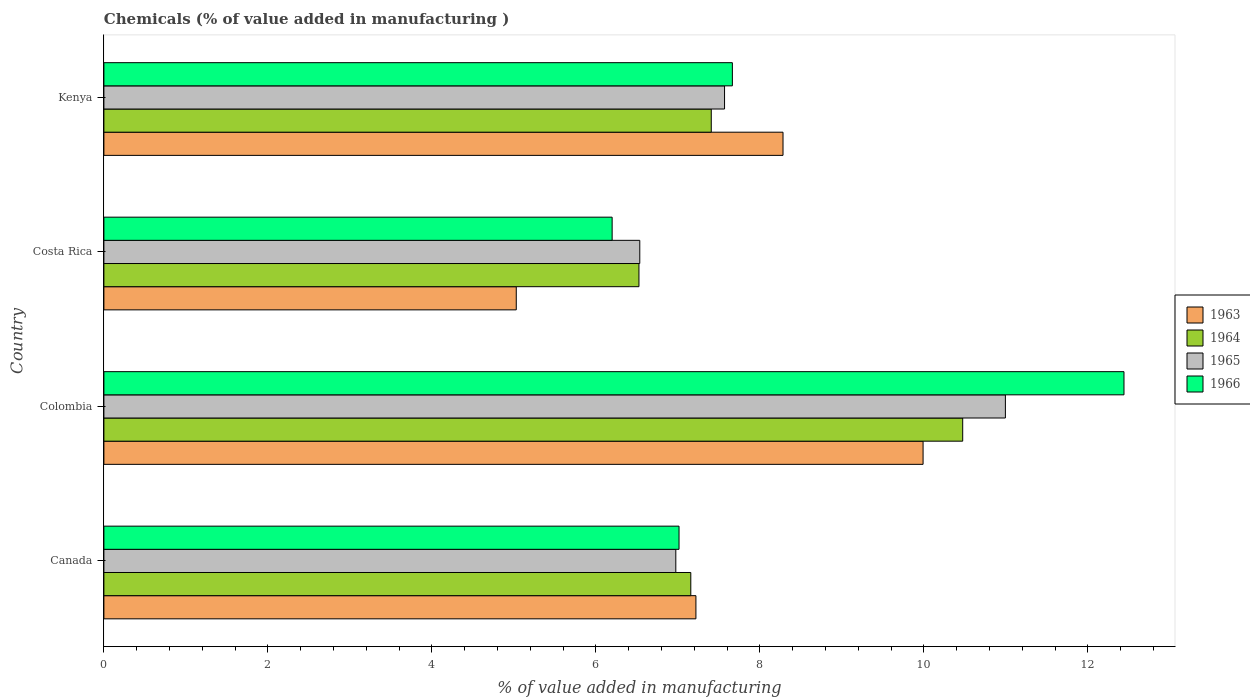Are the number of bars per tick equal to the number of legend labels?
Make the answer very short. Yes. Are the number of bars on each tick of the Y-axis equal?
Your answer should be compact. Yes. How many bars are there on the 1st tick from the bottom?
Your answer should be very brief. 4. What is the label of the 1st group of bars from the top?
Ensure brevity in your answer.  Kenya. What is the value added in manufacturing chemicals in 1963 in Kenya?
Keep it short and to the point. 8.28. Across all countries, what is the maximum value added in manufacturing chemicals in 1964?
Your answer should be very brief. 10.47. Across all countries, what is the minimum value added in manufacturing chemicals in 1965?
Give a very brief answer. 6.54. In which country was the value added in manufacturing chemicals in 1965 maximum?
Offer a very short reply. Colombia. What is the total value added in manufacturing chemicals in 1964 in the graph?
Ensure brevity in your answer.  31.57. What is the difference between the value added in manufacturing chemicals in 1964 in Colombia and that in Kenya?
Provide a succinct answer. 3.07. What is the difference between the value added in manufacturing chemicals in 1964 in Colombia and the value added in manufacturing chemicals in 1966 in Kenya?
Your answer should be compact. 2.81. What is the average value added in manufacturing chemicals in 1965 per country?
Offer a terse response. 8.02. What is the difference between the value added in manufacturing chemicals in 1963 and value added in manufacturing chemicals in 1966 in Costa Rica?
Make the answer very short. -1.17. In how many countries, is the value added in manufacturing chemicals in 1964 greater than 3.6 %?
Provide a succinct answer. 4. What is the ratio of the value added in manufacturing chemicals in 1965 in Colombia to that in Costa Rica?
Your answer should be very brief. 1.68. Is the value added in manufacturing chemicals in 1963 in Canada less than that in Costa Rica?
Give a very brief answer. No. What is the difference between the highest and the second highest value added in manufacturing chemicals in 1964?
Offer a terse response. 3.07. What is the difference between the highest and the lowest value added in manufacturing chemicals in 1965?
Your answer should be compact. 4.46. Is the sum of the value added in manufacturing chemicals in 1965 in Colombia and Kenya greater than the maximum value added in manufacturing chemicals in 1963 across all countries?
Make the answer very short. Yes. What does the 2nd bar from the top in Kenya represents?
Offer a terse response. 1965. What does the 3rd bar from the bottom in Colombia represents?
Offer a very short reply. 1965. Is it the case that in every country, the sum of the value added in manufacturing chemicals in 1965 and value added in manufacturing chemicals in 1966 is greater than the value added in manufacturing chemicals in 1963?
Keep it short and to the point. Yes. How many bars are there?
Your response must be concise. 16. Does the graph contain any zero values?
Your answer should be very brief. No. Where does the legend appear in the graph?
Ensure brevity in your answer.  Center right. What is the title of the graph?
Ensure brevity in your answer.  Chemicals (% of value added in manufacturing ). Does "1991" appear as one of the legend labels in the graph?
Your response must be concise. No. What is the label or title of the X-axis?
Give a very brief answer. % of value added in manufacturing. What is the label or title of the Y-axis?
Offer a very short reply. Country. What is the % of value added in manufacturing of 1963 in Canada?
Offer a terse response. 7.22. What is the % of value added in manufacturing of 1964 in Canada?
Your answer should be very brief. 7.16. What is the % of value added in manufacturing of 1965 in Canada?
Your answer should be very brief. 6.98. What is the % of value added in manufacturing in 1966 in Canada?
Your response must be concise. 7.01. What is the % of value added in manufacturing of 1963 in Colombia?
Your answer should be very brief. 9.99. What is the % of value added in manufacturing in 1964 in Colombia?
Your response must be concise. 10.47. What is the % of value added in manufacturing of 1965 in Colombia?
Provide a succinct answer. 10.99. What is the % of value added in manufacturing in 1966 in Colombia?
Provide a short and direct response. 12.44. What is the % of value added in manufacturing in 1963 in Costa Rica?
Your answer should be very brief. 5.03. What is the % of value added in manufacturing in 1964 in Costa Rica?
Your answer should be very brief. 6.53. What is the % of value added in manufacturing in 1965 in Costa Rica?
Offer a very short reply. 6.54. What is the % of value added in manufacturing in 1966 in Costa Rica?
Keep it short and to the point. 6.2. What is the % of value added in manufacturing of 1963 in Kenya?
Your answer should be compact. 8.28. What is the % of value added in manufacturing of 1964 in Kenya?
Give a very brief answer. 7.41. What is the % of value added in manufacturing of 1965 in Kenya?
Keep it short and to the point. 7.57. What is the % of value added in manufacturing in 1966 in Kenya?
Offer a terse response. 7.67. Across all countries, what is the maximum % of value added in manufacturing in 1963?
Your answer should be compact. 9.99. Across all countries, what is the maximum % of value added in manufacturing of 1964?
Keep it short and to the point. 10.47. Across all countries, what is the maximum % of value added in manufacturing of 1965?
Offer a very short reply. 10.99. Across all countries, what is the maximum % of value added in manufacturing in 1966?
Make the answer very short. 12.44. Across all countries, what is the minimum % of value added in manufacturing in 1963?
Offer a terse response. 5.03. Across all countries, what is the minimum % of value added in manufacturing in 1964?
Provide a succinct answer. 6.53. Across all countries, what is the minimum % of value added in manufacturing in 1965?
Provide a succinct answer. 6.54. Across all countries, what is the minimum % of value added in manufacturing in 1966?
Make the answer very short. 6.2. What is the total % of value added in manufacturing in 1963 in the graph?
Make the answer very short. 30.52. What is the total % of value added in manufacturing in 1964 in the graph?
Give a very brief answer. 31.57. What is the total % of value added in manufacturing of 1965 in the graph?
Offer a very short reply. 32.08. What is the total % of value added in manufacturing of 1966 in the graph?
Offer a very short reply. 33.32. What is the difference between the % of value added in manufacturing in 1963 in Canada and that in Colombia?
Keep it short and to the point. -2.77. What is the difference between the % of value added in manufacturing of 1964 in Canada and that in Colombia?
Ensure brevity in your answer.  -3.32. What is the difference between the % of value added in manufacturing in 1965 in Canada and that in Colombia?
Make the answer very short. -4.02. What is the difference between the % of value added in manufacturing in 1966 in Canada and that in Colombia?
Your answer should be very brief. -5.43. What is the difference between the % of value added in manufacturing of 1963 in Canada and that in Costa Rica?
Your answer should be very brief. 2.19. What is the difference between the % of value added in manufacturing in 1964 in Canada and that in Costa Rica?
Keep it short and to the point. 0.63. What is the difference between the % of value added in manufacturing of 1965 in Canada and that in Costa Rica?
Offer a very short reply. 0.44. What is the difference between the % of value added in manufacturing in 1966 in Canada and that in Costa Rica?
Give a very brief answer. 0.82. What is the difference between the % of value added in manufacturing of 1963 in Canada and that in Kenya?
Your response must be concise. -1.06. What is the difference between the % of value added in manufacturing in 1964 in Canada and that in Kenya?
Provide a short and direct response. -0.25. What is the difference between the % of value added in manufacturing in 1965 in Canada and that in Kenya?
Your answer should be compact. -0.59. What is the difference between the % of value added in manufacturing in 1966 in Canada and that in Kenya?
Keep it short and to the point. -0.65. What is the difference between the % of value added in manufacturing of 1963 in Colombia and that in Costa Rica?
Keep it short and to the point. 4.96. What is the difference between the % of value added in manufacturing of 1964 in Colombia and that in Costa Rica?
Your response must be concise. 3.95. What is the difference between the % of value added in manufacturing of 1965 in Colombia and that in Costa Rica?
Make the answer very short. 4.46. What is the difference between the % of value added in manufacturing of 1966 in Colombia and that in Costa Rica?
Ensure brevity in your answer.  6.24. What is the difference between the % of value added in manufacturing of 1963 in Colombia and that in Kenya?
Offer a very short reply. 1.71. What is the difference between the % of value added in manufacturing of 1964 in Colombia and that in Kenya?
Offer a very short reply. 3.07. What is the difference between the % of value added in manufacturing in 1965 in Colombia and that in Kenya?
Your response must be concise. 3.43. What is the difference between the % of value added in manufacturing of 1966 in Colombia and that in Kenya?
Offer a very short reply. 4.78. What is the difference between the % of value added in manufacturing in 1963 in Costa Rica and that in Kenya?
Provide a short and direct response. -3.25. What is the difference between the % of value added in manufacturing in 1964 in Costa Rica and that in Kenya?
Your answer should be compact. -0.88. What is the difference between the % of value added in manufacturing of 1965 in Costa Rica and that in Kenya?
Provide a succinct answer. -1.03. What is the difference between the % of value added in manufacturing of 1966 in Costa Rica and that in Kenya?
Your answer should be compact. -1.47. What is the difference between the % of value added in manufacturing of 1963 in Canada and the % of value added in manufacturing of 1964 in Colombia?
Make the answer very short. -3.25. What is the difference between the % of value added in manufacturing in 1963 in Canada and the % of value added in manufacturing in 1965 in Colombia?
Your answer should be very brief. -3.77. What is the difference between the % of value added in manufacturing in 1963 in Canada and the % of value added in manufacturing in 1966 in Colombia?
Your response must be concise. -5.22. What is the difference between the % of value added in manufacturing of 1964 in Canada and the % of value added in manufacturing of 1965 in Colombia?
Provide a succinct answer. -3.84. What is the difference between the % of value added in manufacturing of 1964 in Canada and the % of value added in manufacturing of 1966 in Colombia?
Make the answer very short. -5.28. What is the difference between the % of value added in manufacturing of 1965 in Canada and the % of value added in manufacturing of 1966 in Colombia?
Provide a short and direct response. -5.47. What is the difference between the % of value added in manufacturing of 1963 in Canada and the % of value added in manufacturing of 1964 in Costa Rica?
Ensure brevity in your answer.  0.69. What is the difference between the % of value added in manufacturing in 1963 in Canada and the % of value added in manufacturing in 1965 in Costa Rica?
Make the answer very short. 0.68. What is the difference between the % of value added in manufacturing in 1963 in Canada and the % of value added in manufacturing in 1966 in Costa Rica?
Offer a terse response. 1.02. What is the difference between the % of value added in manufacturing in 1964 in Canada and the % of value added in manufacturing in 1965 in Costa Rica?
Your answer should be compact. 0.62. What is the difference between the % of value added in manufacturing in 1964 in Canada and the % of value added in manufacturing in 1966 in Costa Rica?
Your response must be concise. 0.96. What is the difference between the % of value added in manufacturing of 1965 in Canada and the % of value added in manufacturing of 1966 in Costa Rica?
Ensure brevity in your answer.  0.78. What is the difference between the % of value added in manufacturing in 1963 in Canada and the % of value added in manufacturing in 1964 in Kenya?
Your answer should be very brief. -0.19. What is the difference between the % of value added in manufacturing of 1963 in Canada and the % of value added in manufacturing of 1965 in Kenya?
Ensure brevity in your answer.  -0.35. What is the difference between the % of value added in manufacturing in 1963 in Canada and the % of value added in manufacturing in 1966 in Kenya?
Offer a terse response. -0.44. What is the difference between the % of value added in manufacturing in 1964 in Canada and the % of value added in manufacturing in 1965 in Kenya?
Give a very brief answer. -0.41. What is the difference between the % of value added in manufacturing in 1964 in Canada and the % of value added in manufacturing in 1966 in Kenya?
Make the answer very short. -0.51. What is the difference between the % of value added in manufacturing in 1965 in Canada and the % of value added in manufacturing in 1966 in Kenya?
Your answer should be compact. -0.69. What is the difference between the % of value added in manufacturing of 1963 in Colombia and the % of value added in manufacturing of 1964 in Costa Rica?
Provide a short and direct response. 3.47. What is the difference between the % of value added in manufacturing of 1963 in Colombia and the % of value added in manufacturing of 1965 in Costa Rica?
Offer a very short reply. 3.46. What is the difference between the % of value added in manufacturing of 1963 in Colombia and the % of value added in manufacturing of 1966 in Costa Rica?
Keep it short and to the point. 3.79. What is the difference between the % of value added in manufacturing of 1964 in Colombia and the % of value added in manufacturing of 1965 in Costa Rica?
Your answer should be very brief. 3.94. What is the difference between the % of value added in manufacturing in 1964 in Colombia and the % of value added in manufacturing in 1966 in Costa Rica?
Your answer should be very brief. 4.28. What is the difference between the % of value added in manufacturing in 1965 in Colombia and the % of value added in manufacturing in 1966 in Costa Rica?
Offer a terse response. 4.8. What is the difference between the % of value added in manufacturing of 1963 in Colombia and the % of value added in manufacturing of 1964 in Kenya?
Make the answer very short. 2.58. What is the difference between the % of value added in manufacturing of 1963 in Colombia and the % of value added in manufacturing of 1965 in Kenya?
Ensure brevity in your answer.  2.42. What is the difference between the % of value added in manufacturing in 1963 in Colombia and the % of value added in manufacturing in 1966 in Kenya?
Offer a very short reply. 2.33. What is the difference between the % of value added in manufacturing in 1964 in Colombia and the % of value added in manufacturing in 1965 in Kenya?
Make the answer very short. 2.9. What is the difference between the % of value added in manufacturing of 1964 in Colombia and the % of value added in manufacturing of 1966 in Kenya?
Give a very brief answer. 2.81. What is the difference between the % of value added in manufacturing in 1965 in Colombia and the % of value added in manufacturing in 1966 in Kenya?
Offer a terse response. 3.33. What is the difference between the % of value added in manufacturing of 1963 in Costa Rica and the % of value added in manufacturing of 1964 in Kenya?
Your answer should be very brief. -2.38. What is the difference between the % of value added in manufacturing in 1963 in Costa Rica and the % of value added in manufacturing in 1965 in Kenya?
Your response must be concise. -2.54. What is the difference between the % of value added in manufacturing in 1963 in Costa Rica and the % of value added in manufacturing in 1966 in Kenya?
Offer a very short reply. -2.64. What is the difference between the % of value added in manufacturing in 1964 in Costa Rica and the % of value added in manufacturing in 1965 in Kenya?
Your response must be concise. -1.04. What is the difference between the % of value added in manufacturing in 1964 in Costa Rica and the % of value added in manufacturing in 1966 in Kenya?
Provide a short and direct response. -1.14. What is the difference between the % of value added in manufacturing in 1965 in Costa Rica and the % of value added in manufacturing in 1966 in Kenya?
Give a very brief answer. -1.13. What is the average % of value added in manufacturing in 1963 per country?
Offer a very short reply. 7.63. What is the average % of value added in manufacturing of 1964 per country?
Your answer should be very brief. 7.89. What is the average % of value added in manufacturing in 1965 per country?
Ensure brevity in your answer.  8.02. What is the average % of value added in manufacturing of 1966 per country?
Make the answer very short. 8.33. What is the difference between the % of value added in manufacturing in 1963 and % of value added in manufacturing in 1964 in Canada?
Your answer should be compact. 0.06. What is the difference between the % of value added in manufacturing in 1963 and % of value added in manufacturing in 1965 in Canada?
Ensure brevity in your answer.  0.25. What is the difference between the % of value added in manufacturing of 1963 and % of value added in manufacturing of 1966 in Canada?
Your answer should be very brief. 0.21. What is the difference between the % of value added in manufacturing in 1964 and % of value added in manufacturing in 1965 in Canada?
Give a very brief answer. 0.18. What is the difference between the % of value added in manufacturing in 1964 and % of value added in manufacturing in 1966 in Canada?
Offer a terse response. 0.14. What is the difference between the % of value added in manufacturing of 1965 and % of value added in manufacturing of 1966 in Canada?
Your answer should be very brief. -0.04. What is the difference between the % of value added in manufacturing of 1963 and % of value added in manufacturing of 1964 in Colombia?
Provide a short and direct response. -0.48. What is the difference between the % of value added in manufacturing in 1963 and % of value added in manufacturing in 1965 in Colombia?
Your answer should be very brief. -1. What is the difference between the % of value added in manufacturing in 1963 and % of value added in manufacturing in 1966 in Colombia?
Provide a succinct answer. -2.45. What is the difference between the % of value added in manufacturing in 1964 and % of value added in manufacturing in 1965 in Colombia?
Provide a short and direct response. -0.52. What is the difference between the % of value added in manufacturing of 1964 and % of value added in manufacturing of 1966 in Colombia?
Your answer should be very brief. -1.97. What is the difference between the % of value added in manufacturing in 1965 and % of value added in manufacturing in 1966 in Colombia?
Give a very brief answer. -1.45. What is the difference between the % of value added in manufacturing of 1963 and % of value added in manufacturing of 1964 in Costa Rica?
Your answer should be very brief. -1.5. What is the difference between the % of value added in manufacturing of 1963 and % of value added in manufacturing of 1965 in Costa Rica?
Your answer should be very brief. -1.51. What is the difference between the % of value added in manufacturing of 1963 and % of value added in manufacturing of 1966 in Costa Rica?
Make the answer very short. -1.17. What is the difference between the % of value added in manufacturing in 1964 and % of value added in manufacturing in 1965 in Costa Rica?
Give a very brief answer. -0.01. What is the difference between the % of value added in manufacturing in 1964 and % of value added in manufacturing in 1966 in Costa Rica?
Provide a short and direct response. 0.33. What is the difference between the % of value added in manufacturing in 1965 and % of value added in manufacturing in 1966 in Costa Rica?
Provide a short and direct response. 0.34. What is the difference between the % of value added in manufacturing of 1963 and % of value added in manufacturing of 1964 in Kenya?
Offer a very short reply. 0.87. What is the difference between the % of value added in manufacturing of 1963 and % of value added in manufacturing of 1965 in Kenya?
Your answer should be very brief. 0.71. What is the difference between the % of value added in manufacturing in 1963 and % of value added in manufacturing in 1966 in Kenya?
Give a very brief answer. 0.62. What is the difference between the % of value added in manufacturing of 1964 and % of value added in manufacturing of 1965 in Kenya?
Provide a succinct answer. -0.16. What is the difference between the % of value added in manufacturing in 1964 and % of value added in manufacturing in 1966 in Kenya?
Your response must be concise. -0.26. What is the difference between the % of value added in manufacturing in 1965 and % of value added in manufacturing in 1966 in Kenya?
Ensure brevity in your answer.  -0.1. What is the ratio of the % of value added in manufacturing of 1963 in Canada to that in Colombia?
Ensure brevity in your answer.  0.72. What is the ratio of the % of value added in manufacturing of 1964 in Canada to that in Colombia?
Keep it short and to the point. 0.68. What is the ratio of the % of value added in manufacturing of 1965 in Canada to that in Colombia?
Your answer should be compact. 0.63. What is the ratio of the % of value added in manufacturing in 1966 in Canada to that in Colombia?
Offer a terse response. 0.56. What is the ratio of the % of value added in manufacturing in 1963 in Canada to that in Costa Rica?
Keep it short and to the point. 1.44. What is the ratio of the % of value added in manufacturing in 1964 in Canada to that in Costa Rica?
Provide a short and direct response. 1.1. What is the ratio of the % of value added in manufacturing in 1965 in Canada to that in Costa Rica?
Give a very brief answer. 1.07. What is the ratio of the % of value added in manufacturing of 1966 in Canada to that in Costa Rica?
Ensure brevity in your answer.  1.13. What is the ratio of the % of value added in manufacturing in 1963 in Canada to that in Kenya?
Your answer should be compact. 0.87. What is the ratio of the % of value added in manufacturing of 1964 in Canada to that in Kenya?
Offer a very short reply. 0.97. What is the ratio of the % of value added in manufacturing of 1965 in Canada to that in Kenya?
Offer a very short reply. 0.92. What is the ratio of the % of value added in manufacturing of 1966 in Canada to that in Kenya?
Ensure brevity in your answer.  0.92. What is the ratio of the % of value added in manufacturing in 1963 in Colombia to that in Costa Rica?
Your answer should be compact. 1.99. What is the ratio of the % of value added in manufacturing of 1964 in Colombia to that in Costa Rica?
Your response must be concise. 1.61. What is the ratio of the % of value added in manufacturing in 1965 in Colombia to that in Costa Rica?
Make the answer very short. 1.68. What is the ratio of the % of value added in manufacturing of 1966 in Colombia to that in Costa Rica?
Offer a very short reply. 2.01. What is the ratio of the % of value added in manufacturing of 1963 in Colombia to that in Kenya?
Ensure brevity in your answer.  1.21. What is the ratio of the % of value added in manufacturing of 1964 in Colombia to that in Kenya?
Provide a short and direct response. 1.41. What is the ratio of the % of value added in manufacturing in 1965 in Colombia to that in Kenya?
Make the answer very short. 1.45. What is the ratio of the % of value added in manufacturing of 1966 in Colombia to that in Kenya?
Ensure brevity in your answer.  1.62. What is the ratio of the % of value added in manufacturing of 1963 in Costa Rica to that in Kenya?
Give a very brief answer. 0.61. What is the ratio of the % of value added in manufacturing of 1964 in Costa Rica to that in Kenya?
Keep it short and to the point. 0.88. What is the ratio of the % of value added in manufacturing in 1965 in Costa Rica to that in Kenya?
Ensure brevity in your answer.  0.86. What is the ratio of the % of value added in manufacturing of 1966 in Costa Rica to that in Kenya?
Your answer should be compact. 0.81. What is the difference between the highest and the second highest % of value added in manufacturing in 1963?
Give a very brief answer. 1.71. What is the difference between the highest and the second highest % of value added in manufacturing of 1964?
Offer a terse response. 3.07. What is the difference between the highest and the second highest % of value added in manufacturing of 1965?
Provide a succinct answer. 3.43. What is the difference between the highest and the second highest % of value added in manufacturing in 1966?
Offer a terse response. 4.78. What is the difference between the highest and the lowest % of value added in manufacturing in 1963?
Offer a terse response. 4.96. What is the difference between the highest and the lowest % of value added in manufacturing of 1964?
Keep it short and to the point. 3.95. What is the difference between the highest and the lowest % of value added in manufacturing in 1965?
Provide a short and direct response. 4.46. What is the difference between the highest and the lowest % of value added in manufacturing in 1966?
Your answer should be compact. 6.24. 